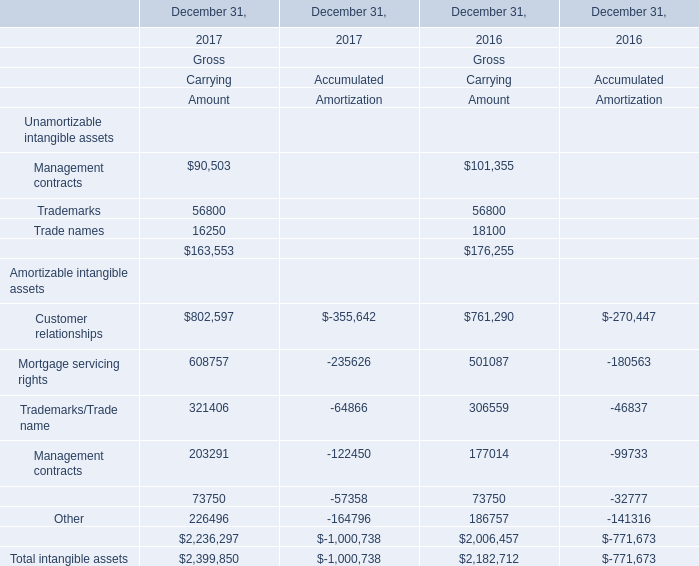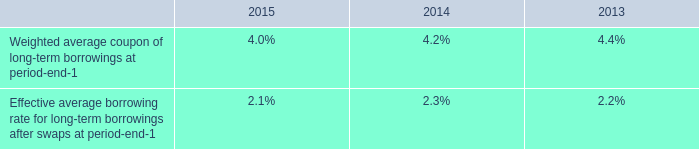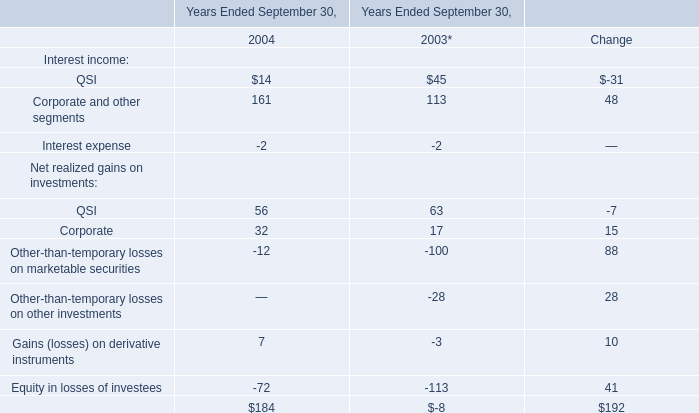Does the value of Management contracts in 2017 greater than that in 2016 ? (in thousand) 
Answer: 90503.0. 